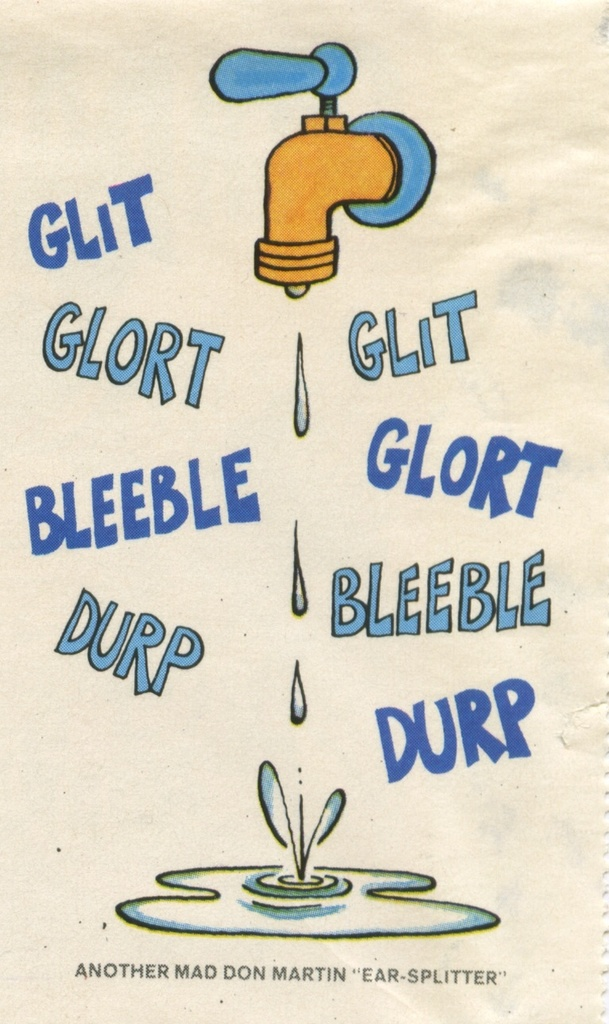What do you see happening in this image? The image presents a cartoon illustration of a blue faucet, from which water is dripping into a small puddle below. Surrounding the faucet are nonsensical sound effect words such as "glit", "glort", "bleeble", and "durp". These words seem to be a playful representation of the sounds one might imagine the dripping faucet to make. The image is humorously captioned "Another Mad Don Martin 'Ear-Splitter'", suggesting that the depicted scene is intended to be a comically exaggerated interpretation of the noise a dripping faucet can produce. 